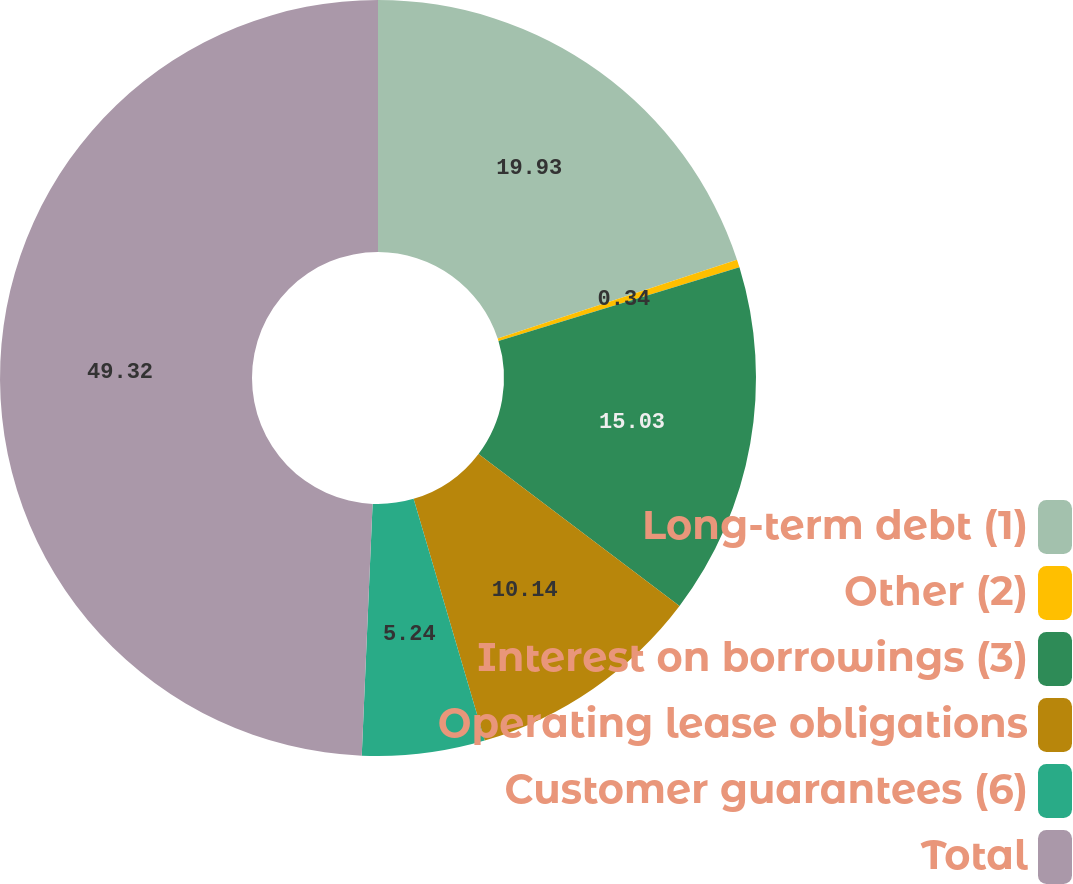Convert chart to OTSL. <chart><loc_0><loc_0><loc_500><loc_500><pie_chart><fcel>Long-term debt (1)<fcel>Other (2)<fcel>Interest on borrowings (3)<fcel>Operating lease obligations<fcel>Customer guarantees (6)<fcel>Total<nl><fcel>19.93%<fcel>0.34%<fcel>15.03%<fcel>10.14%<fcel>5.24%<fcel>49.31%<nl></chart> 